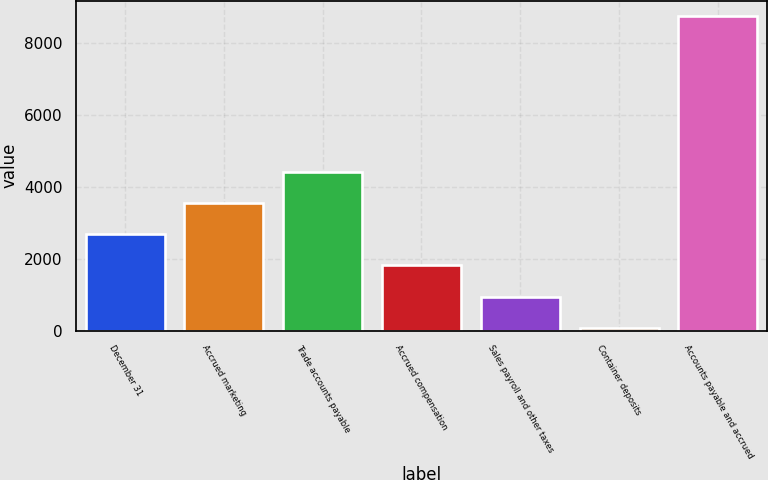Convert chart to OTSL. <chart><loc_0><loc_0><loc_500><loc_500><bar_chart><fcel>December 31<fcel>Accrued marketing<fcel>Trade accounts payable<fcel>Accrued compensation<fcel>Sales payroll and other taxes<fcel>Container deposits<fcel>Accounts payable and accrued<nl><fcel>2680.4<fcel>3547.2<fcel>4414<fcel>1813.6<fcel>946.8<fcel>80<fcel>8748<nl></chart> 